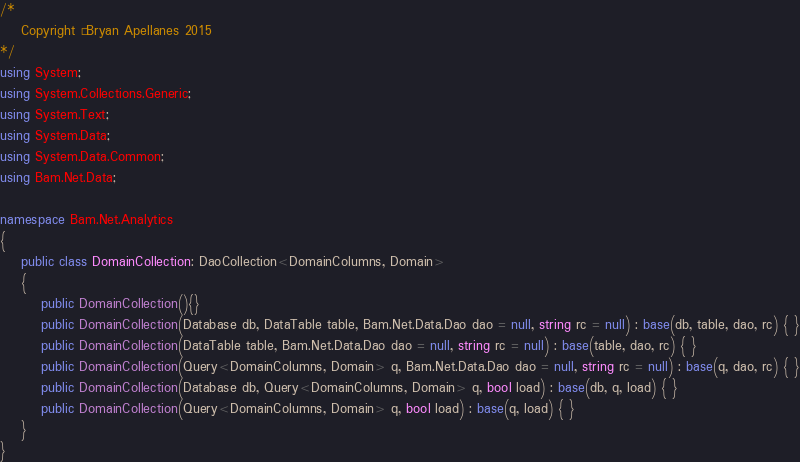<code> <loc_0><loc_0><loc_500><loc_500><_C#_>/*
	Copyright © Bryan Apellanes 2015  
*/
using System;
using System.Collections.Generic;
using System.Text;
using System.Data;
using System.Data.Common;
using Bam.Net.Data;

namespace Bam.Net.Analytics
{
    public class DomainCollection: DaoCollection<DomainColumns, Domain>
    { 
		public DomainCollection(){}
		public DomainCollection(Database db, DataTable table, Bam.Net.Data.Dao dao = null, string rc = null) : base(db, table, dao, rc) { }
		public DomainCollection(DataTable table, Bam.Net.Data.Dao dao = null, string rc = null) : base(table, dao, rc) { }
		public DomainCollection(Query<DomainColumns, Domain> q, Bam.Net.Data.Dao dao = null, string rc = null) : base(q, dao, rc) { }
		public DomainCollection(Database db, Query<DomainColumns, Domain> q, bool load) : base(db, q, load) { }
		public DomainCollection(Query<DomainColumns, Domain> q, bool load) : base(q, load) { }
    }
}</code> 